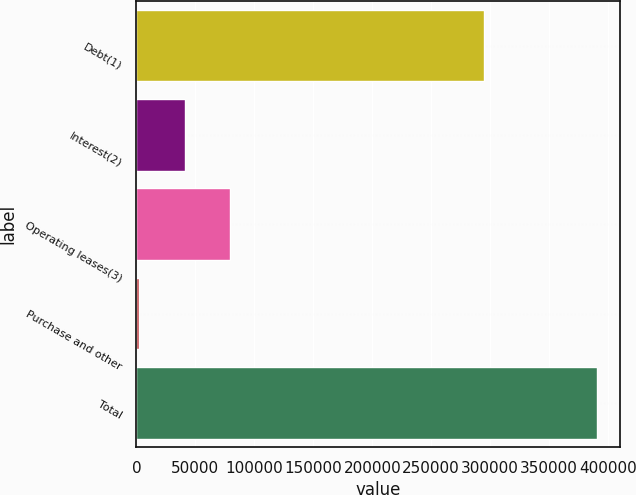Convert chart to OTSL. <chart><loc_0><loc_0><loc_500><loc_500><bar_chart><fcel>Debt(1)<fcel>Interest(2)<fcel>Operating leases(3)<fcel>Purchase and other<fcel>Total<nl><fcel>295080<fcel>40881.3<fcel>79718.6<fcel>2044<fcel>390417<nl></chart> 